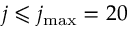Convert formula to latex. <formula><loc_0><loc_0><loc_500><loc_500>j \leqslant j _ { \max } = 2 0</formula> 